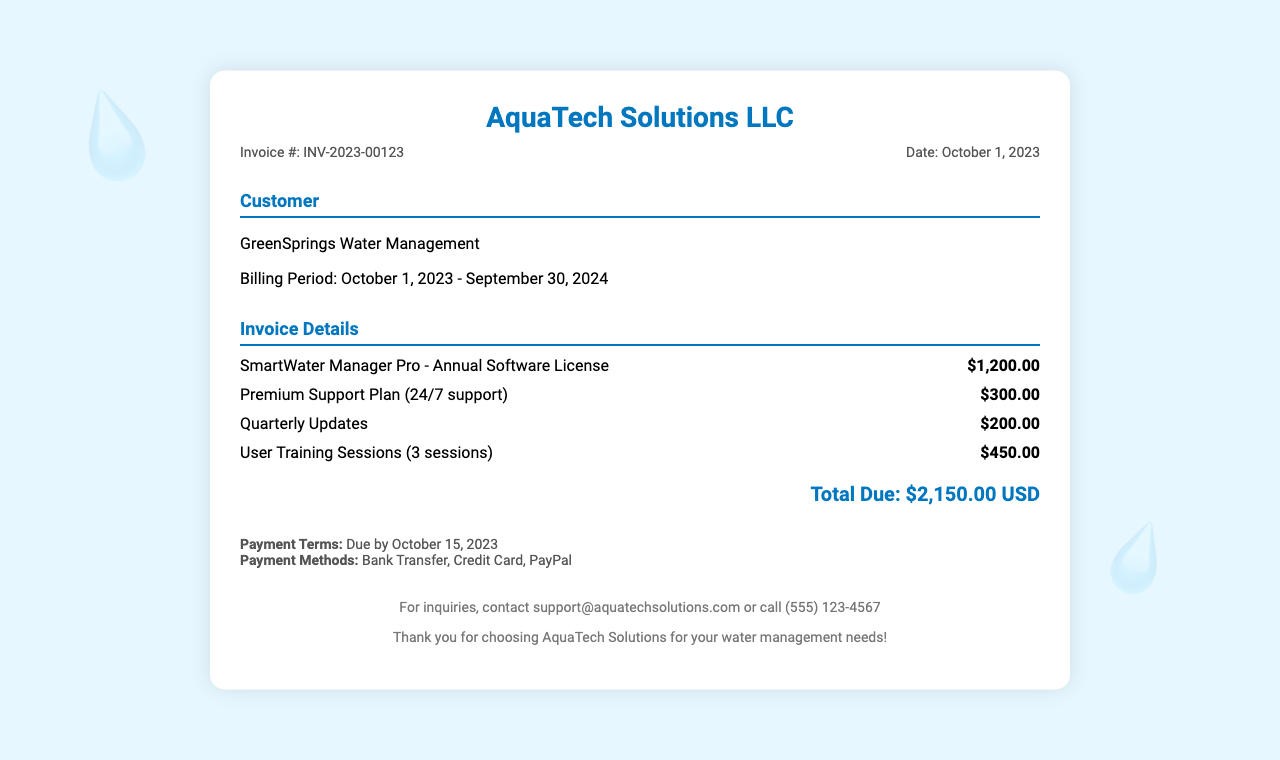What is the invoice number? The invoice number is specified in the document under "Invoice #," which is INV-2023-00123.
Answer: INV-2023-00123 What is the total amount due? The total amount due is clearly stated at the end of the invoice, which sums all charges to $2,150.00.
Answer: $2,150.00 When is the payment due? Payment terms indicate the due date for payment is October 15, 2023.
Answer: October 15, 2023 What is included in the support plan? The document specifies that the Premium Support Plan includes 24/7 support, as outlined in the invoice details.
Answer: 24/7 support How many user training sessions are included? The invoice states that there are 3 user training sessions included in the total charge.
Answer: 3 sessions What is the billing period? The billing period is clearly defined in the customer information section, starting from October 1, 2023, to September 30, 2024.
Answer: October 1, 2023 - September 30, 2024 What company issued this invoice? The company that issued the invoice is AquaTech Solutions LLC, as mentioned in the header of the document.
Answer: AquaTech Solutions LLC What methods of payment are accepted? The invoice lists Bank Transfer, Credit Card, and PayPal as the accepted payment methods.
Answer: Bank Transfer, Credit Card, PayPal What service has a cost of $1,200.00? The document specifies that the SmartWater Manager Pro - Annual Software License is priced at $1,200.00.
Answer: SmartWater Manager Pro - Annual Software License 